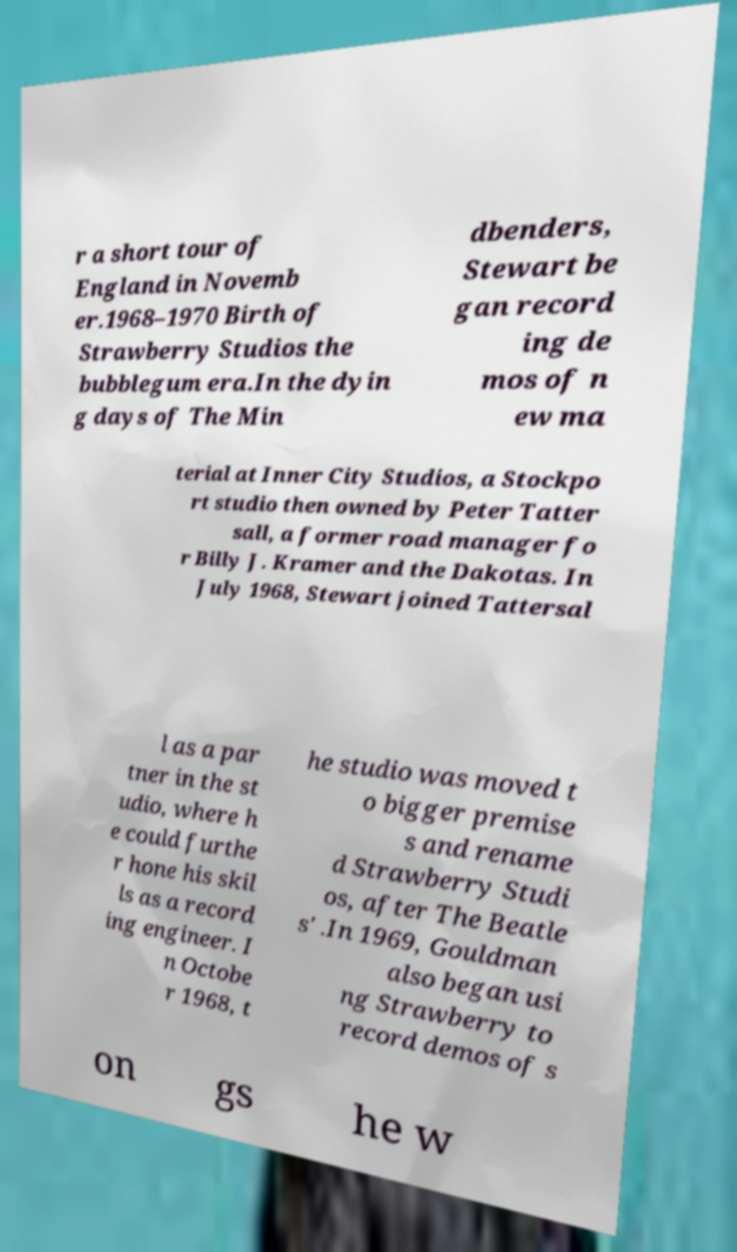Please identify and transcribe the text found in this image. r a short tour of England in Novemb er.1968–1970 Birth of Strawberry Studios the bubblegum era.In the dyin g days of The Min dbenders, Stewart be gan record ing de mos of n ew ma terial at Inner City Studios, a Stockpo rt studio then owned by Peter Tatter sall, a former road manager fo r Billy J. Kramer and the Dakotas. In July 1968, Stewart joined Tattersal l as a par tner in the st udio, where h e could furthe r hone his skil ls as a record ing engineer. I n Octobe r 1968, t he studio was moved t o bigger premise s and rename d Strawberry Studi os, after The Beatle s' .In 1969, Gouldman also began usi ng Strawberry to record demos of s on gs he w 